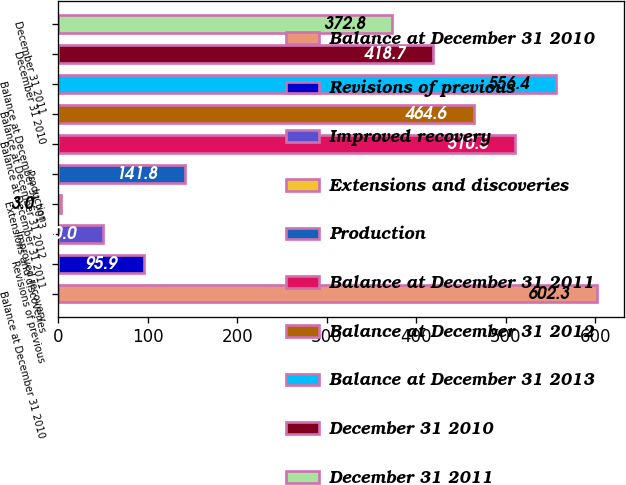<chart> <loc_0><loc_0><loc_500><loc_500><bar_chart><fcel>Balance at December 31 2010<fcel>Revisions of previous<fcel>Improved recovery<fcel>Extensions and discoveries<fcel>Production<fcel>Balance at December 31 2011<fcel>Balance at December 31 2012<fcel>Balance at December 31 2013<fcel>December 31 2010<fcel>December 31 2011<nl><fcel>602.3<fcel>95.9<fcel>50<fcel>3<fcel>141.8<fcel>510.5<fcel>464.6<fcel>556.4<fcel>418.7<fcel>372.8<nl></chart> 